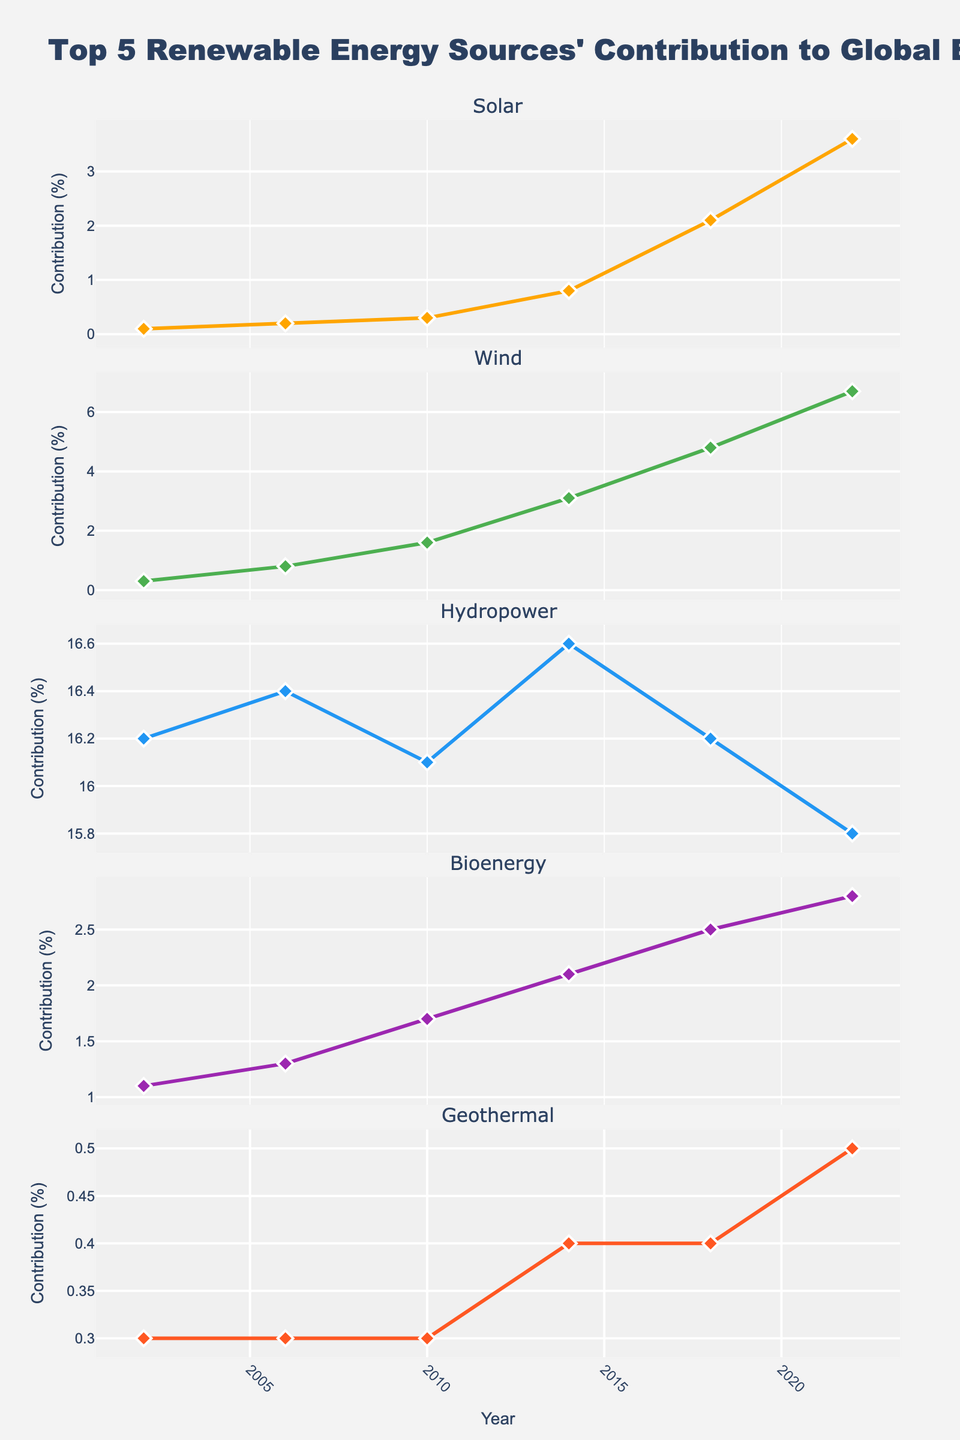What is the overall trend for Solar energy contribution from 2002 to 2022? Observing the Solar energy subplot, the contribution starts at 0.1 in 2002 and gradually increases over time, reaching 3.6 in 2022. This indicates a positive upward trend.
Answer: Positive upward trend In what year did Wind energy first surpass 1% contribution? Looking at the Wind energy subplot, it is seen that the contribution surpasses 1% in 2010 when it reaches 1.6%.
Answer: 2010 Which renewable energy source shows the least variation in contribution over time? Among the five plots, Hydropower's values consistently hover around 16% with minimal fluctuation compared to other sources.
Answer: Hydropower How does the growth rate of Bioenergy from 2002 to 2022 compare to that of Solar energy in the same period? Bioenergy increases from 1.1 to 2.8, which is an increase of 1.7. Solar energy increases from 0.1 to 3.6, which is an increase of 3.5. Thus, Solar energy's growth rate is higher than Bioenergy's.
Answer: Solar energy has a higher growth rate What were the contributions of Geothermal energy in 2002, 2010, and 2022? Looking at the Geothermal subplot, the contributions are 0.3 in 2002, remains 0.3 in 2010, and increases slightly to 0.5 in 2022.
Answer: 0.3, 0.3, 0.5 Between Wind and Bioenergy, which one has shown more consistent growth over the years? Examining the plots for both Wind and Bioenergy, Wind shows a more consistent and steady increase from 0.3 in 2002 to 6.7 in 2022, while Bioenergy increases more gradually and with less consistency.
Answer: Wind During the period from 2014 to 2018, which renewable energy source had the largest increase in contribution? Comparing the increase in each plot from 2014 to 2018: Solar increased from 0.8 to 2.1, Wind increased from 3.1 to 4.8, and other sources show smaller or stable changes. Solar energy had the largest increase.
Answer: Solar What is the common trend observed in all five renewable energy sources over the past 20 years? All sources show an overall upward trend in their contribution percentages, indicating a global increase in renewable energy production.
Answer: Upward trend Which renewable energy source had the highest contribution in 2022? Observing the values in each subplot for 2022, Hydropower consistently holds the highest contribution of 15.8%.
Answer: Hydropower How did the contribution of Hydropower change from 2002 to 2022? Hydropower started at 16.2 in 2002 and slightly decreased to 15.8 in 2022, showing a slight decrease over the period.
Answer: Slight decrease 